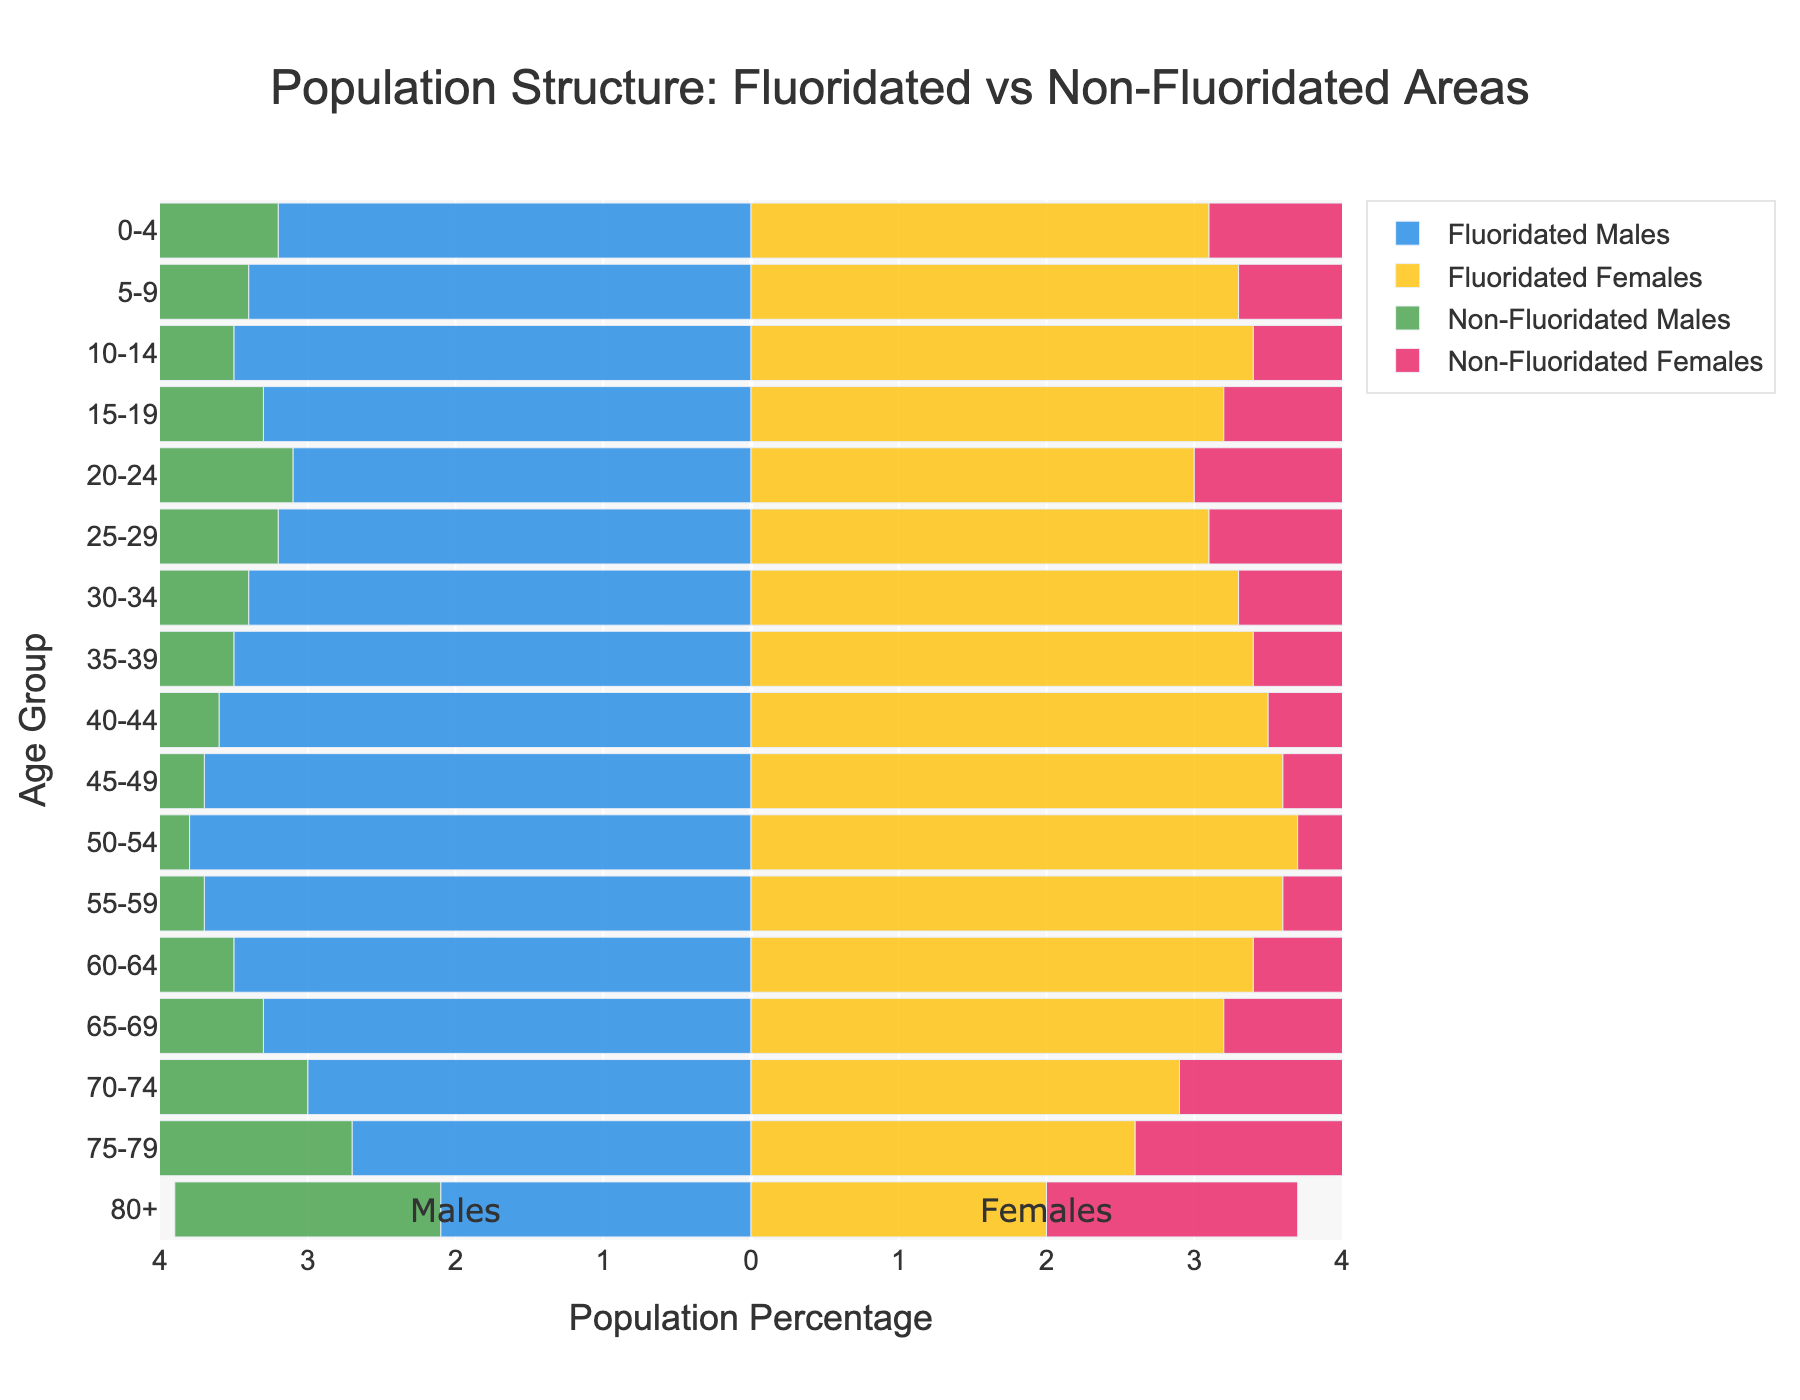How does the percentage of males in the 0-4 age group in fluoridated areas compare to non-fluoridated areas? The plot shows that the percentage of males in the 0-4 age group is 3.2% in fluoridated areas and 3.0% in non-fluoridated areas. Thus, the percentage is higher in fluoridated areas by 0.2%.
Answer: The percentage in fluoridated areas is higher by 0.2% In the age group 80+, which gender has a higher population percentage in non-fluoridated areas? The plot reveals that in the 80+ age group, non-fluoridated areas have 1.8% males and 1.7% females. Therefore, the percentage of males is slightly higher.
Answer: Males What is the total population percentage for the age group 45-49 across both genders in non-fluoridated areas? The plot shows 3.4% for males and 3.3% for females in the non-fluoridated areas for the 45-49 age group. Adding these gives 3.4 + 3.3 = 6.7%.
Answer: 6.7% Which age group in fluoridated areas shows the highest population percentage for females? The plot indicates that the age group 50-54 has the highest percentage of females in fluoridated areas, with 3.7%.
Answer: 50-54 By how much does the percentage of females aged 35-39 in fluoridated areas surpass the percentage of females aged 70-74 in non-fluoridated areas? The plot shows 3.4% for females aged 35-39 in fluoridated areas and 2.6% for females aged 70-74 in non-fluoridated areas. The difference is 3.4 - 2.6 = 0.8%.
Answer: 0.8% What is the percentage difference for males in the 60-64 age group between fluoridated and non-fluoridated areas? The plot shows 3.5% for males in fluoridated areas and 3.2% in non-fluoridated areas in the 60-64 age group. The difference is 3.5 - 3.2 = 0.3%.
Answer: 0.3% Among males in the age group 10-14, where does the population percentage appear higher: in fluoridated or non-fluoridated areas? The plot indicates that the percentage for males aged 10-14 is 3.5% in fluoridated areas and 3.2% in non-fluoridated areas. Therefore, it is higher in fluoridated areas.
Answer: Fluoridated areas Compare the population percentages for females aged 25-29 between fluoridated and non-fluoridated areas. The plot shows females aged 25-29 have a population percentage of 3.1% in fluoridated areas and 2.8% in non-fluoridated areas. Thus, the percentage in fluoridated areas is higher by 0.3%.
Answer: Higher by 0.3% In which age group is the difference in the population percentage of females the smallest between fluoridated and non-fluoridated areas? By examining the plot, the age group 0-4 shows the smallest difference, with females being 3.1% in fluoridated areas and 2.9% in non-fluoridated areas, resulting in a difference of 0.2%.
Answer: 0-4 